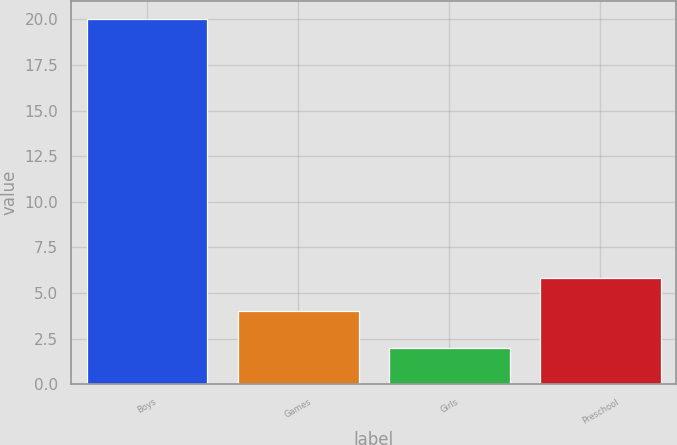Convert chart. <chart><loc_0><loc_0><loc_500><loc_500><bar_chart><fcel>Boys<fcel>Games<fcel>Girls<fcel>Preschool<nl><fcel>20<fcel>4<fcel>2<fcel>5.8<nl></chart> 